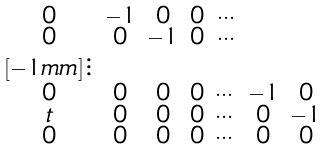Convert formula to latex. <formula><loc_0><loc_0><loc_500><loc_500>\begin{smallmatrix} 0 & - 1 & 0 & 0 & \cdots \\ 0 & 0 & - 1 & 0 & \cdots \\ [ - 1 m m ] \vdots \\ 0 & 0 & 0 & 0 & \cdots & - 1 & 0 \\ t & 0 & 0 & 0 & \cdots & 0 & - 1 \\ 0 & 0 & 0 & 0 & \cdots & 0 & 0 \end{smallmatrix}</formula> 